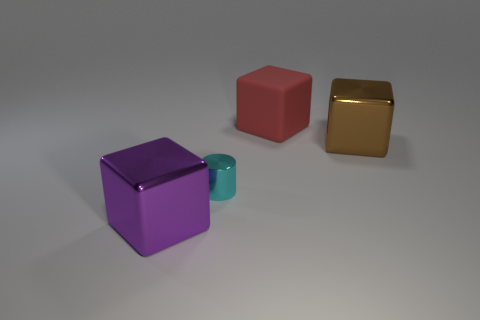Add 3 blocks. How many objects exist? 7 Subtract all cylinders. How many objects are left? 3 Add 3 green cylinders. How many green cylinders exist? 3 Subtract 0 cyan balls. How many objects are left? 4 Subtract all cyan metal objects. Subtract all large red matte objects. How many objects are left? 2 Add 4 shiny things. How many shiny things are left? 7 